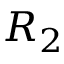<formula> <loc_0><loc_0><loc_500><loc_500>R _ { 2 }</formula> 